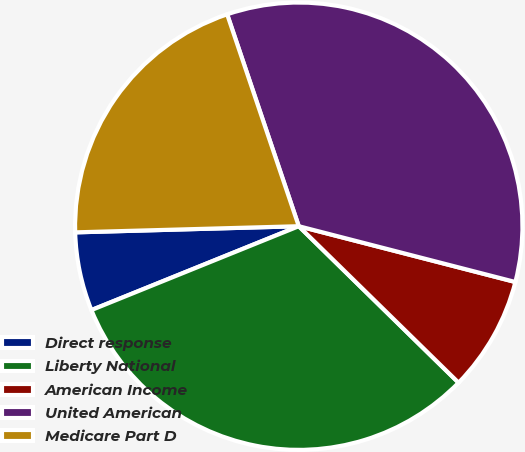<chart> <loc_0><loc_0><loc_500><loc_500><pie_chart><fcel>Direct response<fcel>Liberty National<fcel>American Income<fcel>United American<fcel>Medicare Part D<nl><fcel>5.68%<fcel>31.55%<fcel>8.32%<fcel>34.2%<fcel>20.25%<nl></chart> 